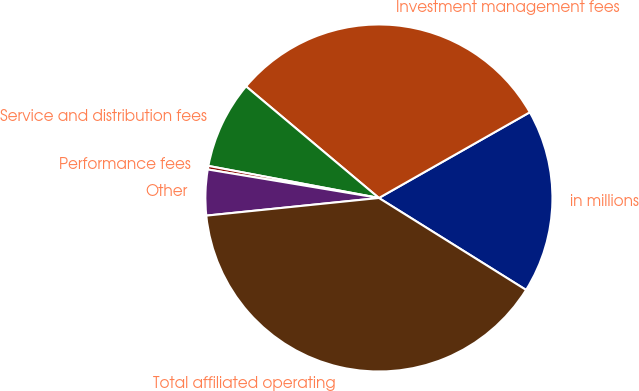Convert chart to OTSL. <chart><loc_0><loc_0><loc_500><loc_500><pie_chart><fcel>in millions<fcel>Investment management fees<fcel>Service and distribution fees<fcel>Performance fees<fcel>Other<fcel>Total affiliated operating<nl><fcel>17.11%<fcel>30.66%<fcel>8.16%<fcel>0.33%<fcel>4.25%<fcel>39.49%<nl></chart> 